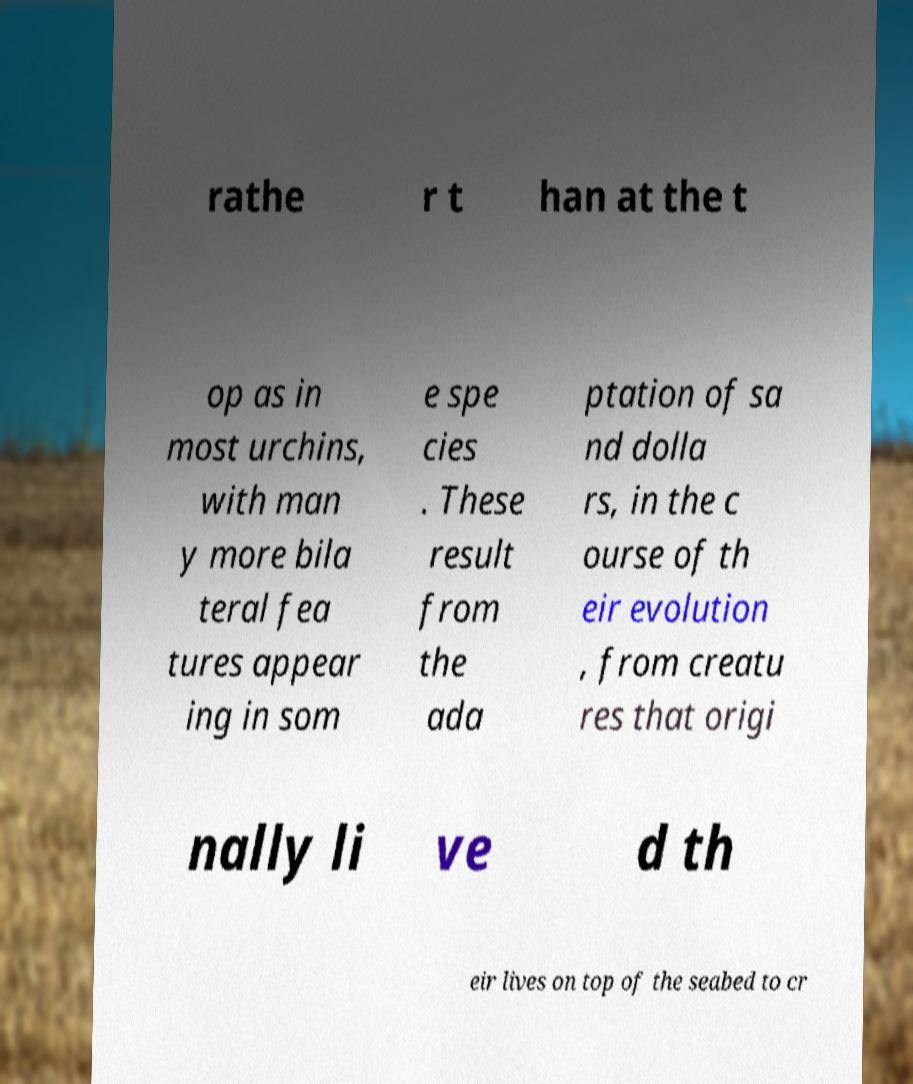Please identify and transcribe the text found in this image. rathe r t han at the t op as in most urchins, with man y more bila teral fea tures appear ing in som e spe cies . These result from the ada ptation of sa nd dolla rs, in the c ourse of th eir evolution , from creatu res that origi nally li ve d th eir lives on top of the seabed to cr 